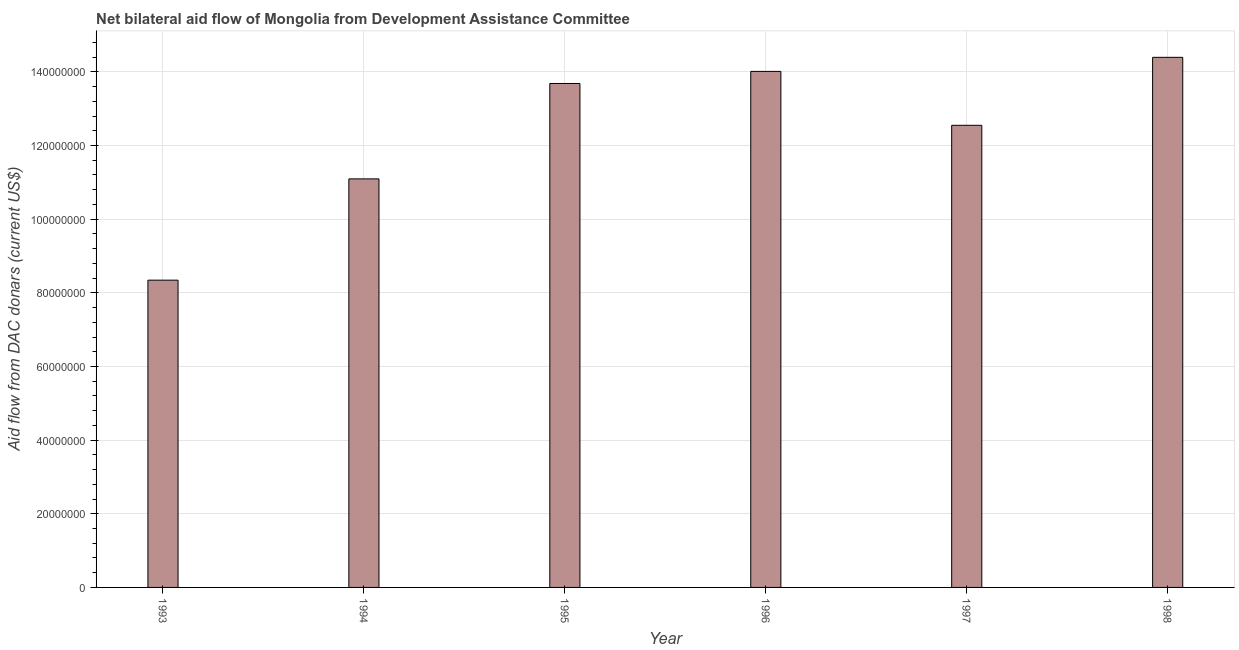Does the graph contain any zero values?
Provide a succinct answer. No. What is the title of the graph?
Your response must be concise. Net bilateral aid flow of Mongolia from Development Assistance Committee. What is the label or title of the Y-axis?
Offer a terse response. Aid flow from DAC donars (current US$). What is the net bilateral aid flows from dac donors in 1997?
Make the answer very short. 1.25e+08. Across all years, what is the maximum net bilateral aid flows from dac donors?
Your answer should be very brief. 1.44e+08. Across all years, what is the minimum net bilateral aid flows from dac donors?
Your answer should be very brief. 8.34e+07. What is the sum of the net bilateral aid flows from dac donors?
Ensure brevity in your answer.  7.41e+08. What is the difference between the net bilateral aid flows from dac donors in 1994 and 1997?
Your answer should be compact. -1.46e+07. What is the average net bilateral aid flows from dac donors per year?
Make the answer very short. 1.23e+08. What is the median net bilateral aid flows from dac donors?
Provide a short and direct response. 1.31e+08. What is the ratio of the net bilateral aid flows from dac donors in 1994 to that in 1998?
Provide a short and direct response. 0.77. What is the difference between the highest and the second highest net bilateral aid flows from dac donors?
Your answer should be very brief. 3.82e+06. Is the sum of the net bilateral aid flows from dac donors in 1994 and 1998 greater than the maximum net bilateral aid flows from dac donors across all years?
Provide a short and direct response. Yes. What is the difference between the highest and the lowest net bilateral aid flows from dac donors?
Offer a very short reply. 6.05e+07. Are all the bars in the graph horizontal?
Offer a terse response. No. Are the values on the major ticks of Y-axis written in scientific E-notation?
Your response must be concise. No. What is the Aid flow from DAC donars (current US$) in 1993?
Ensure brevity in your answer.  8.34e+07. What is the Aid flow from DAC donars (current US$) in 1994?
Give a very brief answer. 1.11e+08. What is the Aid flow from DAC donars (current US$) of 1995?
Give a very brief answer. 1.37e+08. What is the Aid flow from DAC donars (current US$) in 1996?
Make the answer very short. 1.40e+08. What is the Aid flow from DAC donars (current US$) in 1997?
Make the answer very short. 1.25e+08. What is the Aid flow from DAC donars (current US$) of 1998?
Offer a very short reply. 1.44e+08. What is the difference between the Aid flow from DAC donars (current US$) in 1993 and 1994?
Offer a terse response. -2.75e+07. What is the difference between the Aid flow from DAC donars (current US$) in 1993 and 1995?
Give a very brief answer. -5.34e+07. What is the difference between the Aid flow from DAC donars (current US$) in 1993 and 1996?
Your answer should be very brief. -5.67e+07. What is the difference between the Aid flow from DAC donars (current US$) in 1993 and 1997?
Your answer should be very brief. -4.20e+07. What is the difference between the Aid flow from DAC donars (current US$) in 1993 and 1998?
Your response must be concise. -6.05e+07. What is the difference between the Aid flow from DAC donars (current US$) in 1994 and 1995?
Ensure brevity in your answer.  -2.59e+07. What is the difference between the Aid flow from DAC donars (current US$) in 1994 and 1996?
Make the answer very short. -2.92e+07. What is the difference between the Aid flow from DAC donars (current US$) in 1994 and 1997?
Offer a very short reply. -1.46e+07. What is the difference between the Aid flow from DAC donars (current US$) in 1994 and 1998?
Your response must be concise. -3.30e+07. What is the difference between the Aid flow from DAC donars (current US$) in 1995 and 1996?
Keep it short and to the point. -3.28e+06. What is the difference between the Aid flow from DAC donars (current US$) in 1995 and 1997?
Your answer should be very brief. 1.14e+07. What is the difference between the Aid flow from DAC donars (current US$) in 1995 and 1998?
Your answer should be compact. -7.10e+06. What is the difference between the Aid flow from DAC donars (current US$) in 1996 and 1997?
Ensure brevity in your answer.  1.46e+07. What is the difference between the Aid flow from DAC donars (current US$) in 1996 and 1998?
Provide a succinct answer. -3.82e+06. What is the difference between the Aid flow from DAC donars (current US$) in 1997 and 1998?
Offer a very short reply. -1.85e+07. What is the ratio of the Aid flow from DAC donars (current US$) in 1993 to that in 1994?
Provide a short and direct response. 0.75. What is the ratio of the Aid flow from DAC donars (current US$) in 1993 to that in 1995?
Provide a short and direct response. 0.61. What is the ratio of the Aid flow from DAC donars (current US$) in 1993 to that in 1996?
Offer a terse response. 0.59. What is the ratio of the Aid flow from DAC donars (current US$) in 1993 to that in 1997?
Ensure brevity in your answer.  0.67. What is the ratio of the Aid flow from DAC donars (current US$) in 1993 to that in 1998?
Give a very brief answer. 0.58. What is the ratio of the Aid flow from DAC donars (current US$) in 1994 to that in 1995?
Your answer should be very brief. 0.81. What is the ratio of the Aid flow from DAC donars (current US$) in 1994 to that in 1996?
Offer a terse response. 0.79. What is the ratio of the Aid flow from DAC donars (current US$) in 1994 to that in 1997?
Make the answer very short. 0.88. What is the ratio of the Aid flow from DAC donars (current US$) in 1994 to that in 1998?
Offer a very short reply. 0.77. What is the ratio of the Aid flow from DAC donars (current US$) in 1995 to that in 1997?
Your answer should be compact. 1.09. What is the ratio of the Aid flow from DAC donars (current US$) in 1995 to that in 1998?
Provide a succinct answer. 0.95. What is the ratio of the Aid flow from DAC donars (current US$) in 1996 to that in 1997?
Make the answer very short. 1.12. What is the ratio of the Aid flow from DAC donars (current US$) in 1997 to that in 1998?
Your answer should be very brief. 0.87. 